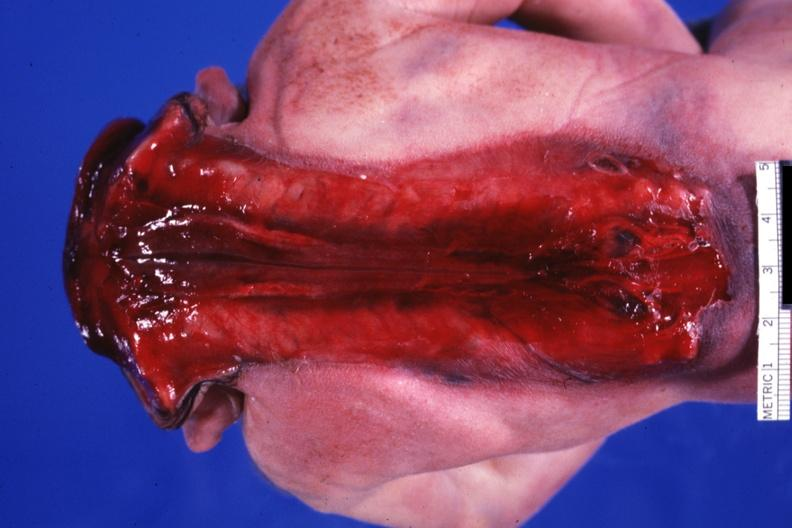does this image show posterior view of whole body to buttocks?
Answer the question using a single word or phrase. Yes 